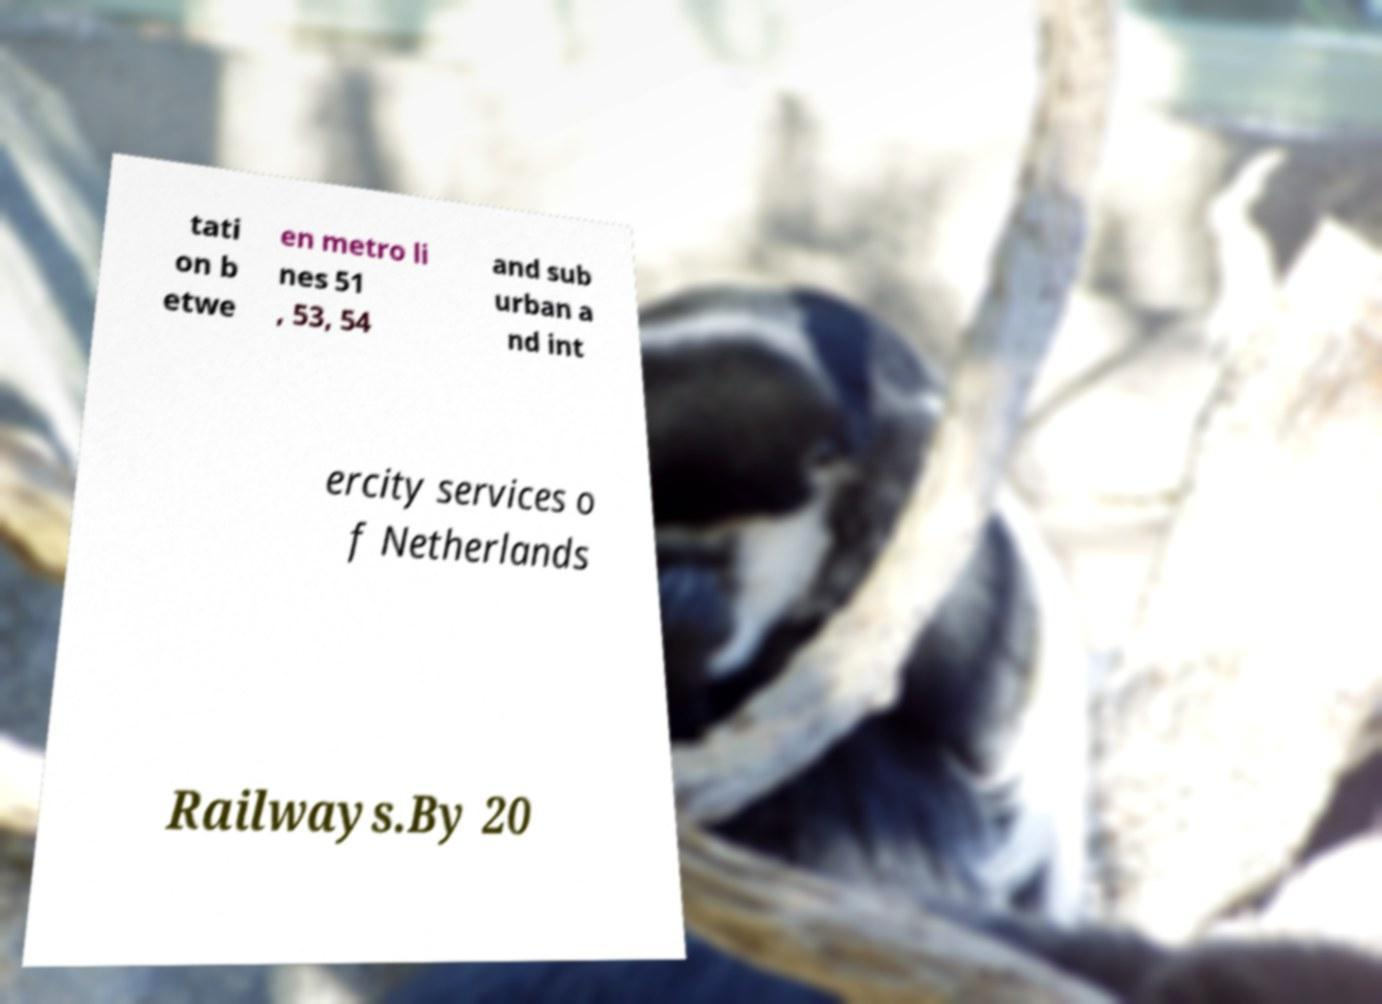Please identify and transcribe the text found in this image. tati on b etwe en metro li nes 51 , 53, 54 and sub urban a nd int ercity services o f Netherlands Railways.By 20 